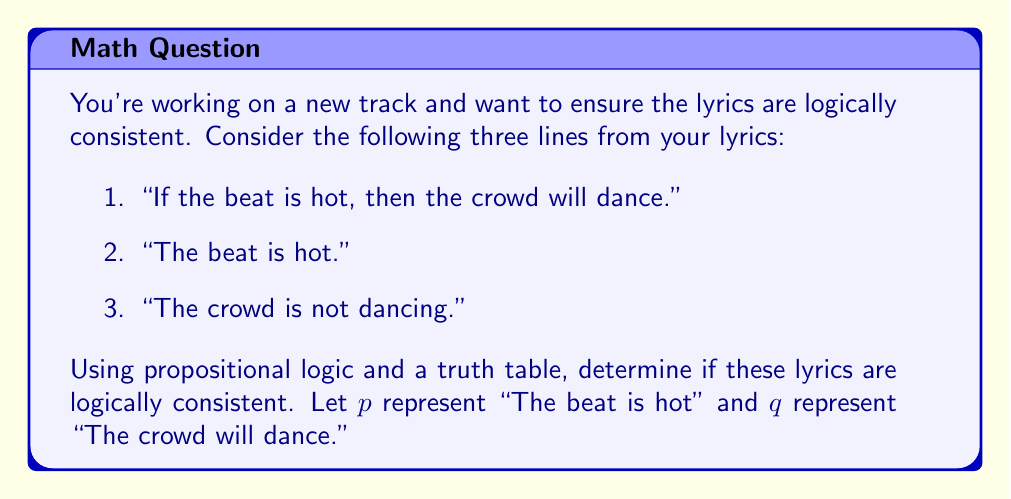Help me with this question. To evaluate the consistency of these lyrics, we need to translate them into propositional logic statements and construct a truth table.

1. "If the beat is hot, then the crowd will dance" translates to $p \rightarrow q$
2. "The beat is hot" is simply $p$
3. "The crowd is not dancing" translates to $\neg q$

Now, let's construct a truth table for the conjunction of these statements: $(p \rightarrow q) \land p \land \neg q$

$$
\begin{array}{|c|c|c|c|c|c|}
\hline
p & q & p \rightarrow q & p & \neg q & (p \rightarrow q) \land p \land \neg q \\
\hline
T & T & T & T & F & F \\
T & F & F & T & T & F \\
F & T & T & F & F & F \\
F & F & T & F & T & F \\
\hline
\end{array}
$$

We evaluate the truth table row by row:

1. When $p$ is true and $q$ is true, $(p \rightarrow q)$ is true, $p$ is true, but $\neg q$ is false. The conjunction is false.
2. When $p$ is true and $q$ is false, $(p \rightarrow q)$ is false, $p$ is true, and $\neg q$ is true. The conjunction is false.
3. When $p$ is false and $q$ is true, $(p \rightarrow q)$ is true, but $p$ is false. The conjunction is false.
4. When $p$ is false and $q$ is false, $(p \rightarrow q)$ is true, but $p$ is false. The conjunction is false.

For the lyrics to be logically consistent, there must be at least one row in the truth table where the final column is true. However, we see that the final column is false for all possible combinations of $p$ and $q$.
Answer: The lyrics are logically inconsistent because there is no row in the truth table where $(p \rightarrow q) \land p \land \neg q$ is true. 